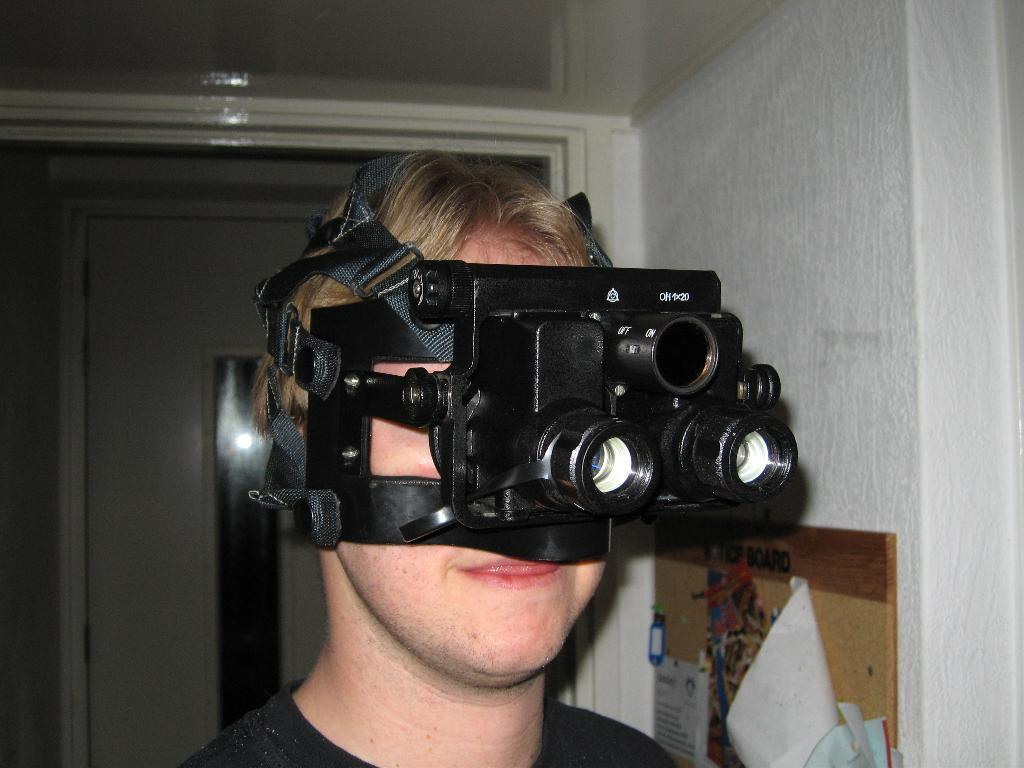What is the main subject of the image? There is a person in the image. What is the person wearing in the image? The person is wearing a VR headset. What can be seen in the background of the image? There is a door in the background of the image. Can you describe the detail of the ocean in the image? There is no ocean present in the image. What type of pet can be seen interacting with the person in the image? There is no pet present in the image. 